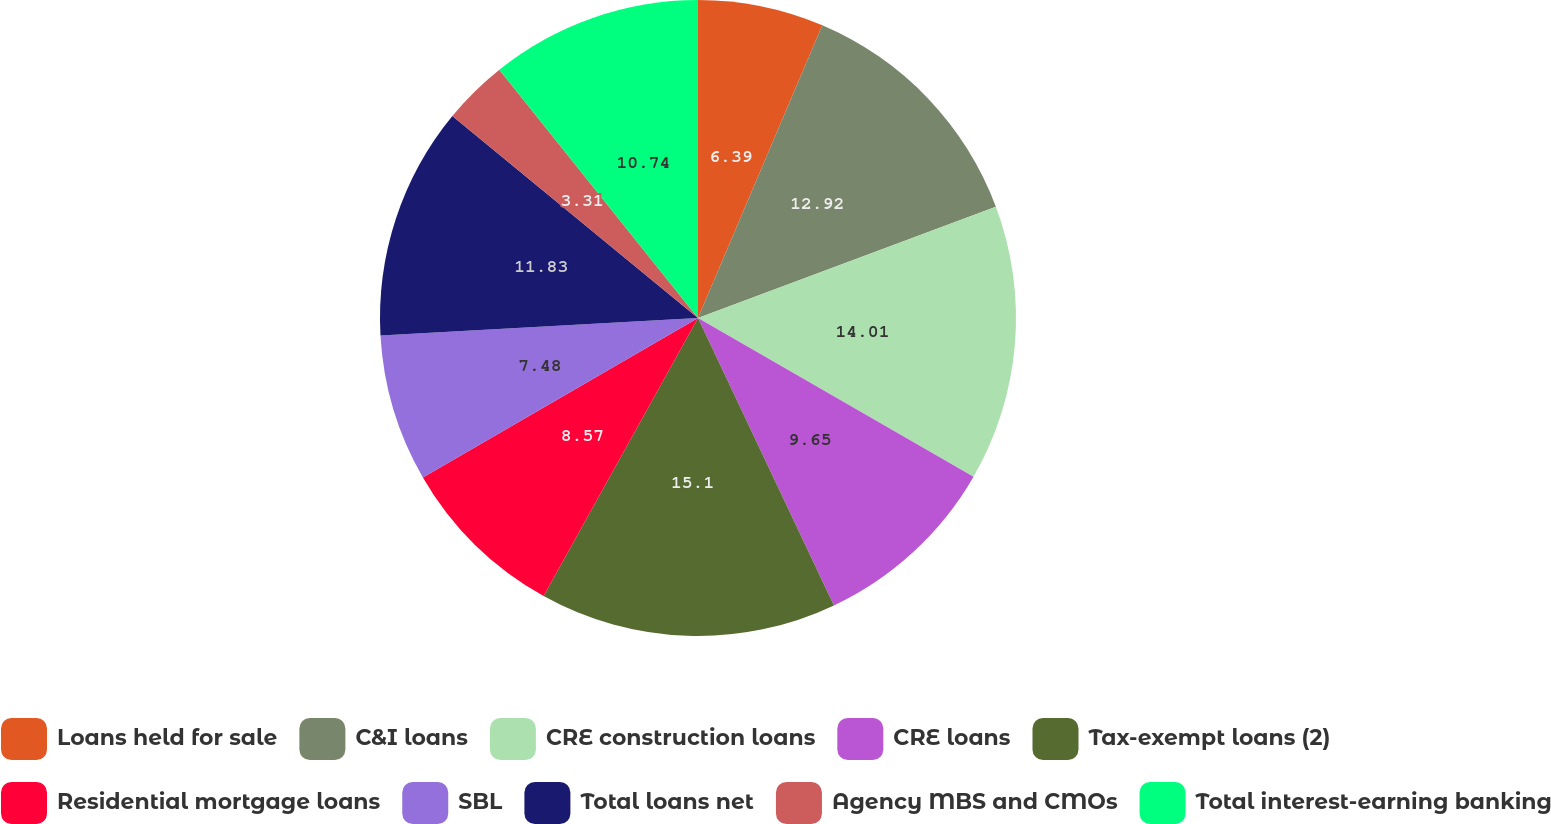Convert chart. <chart><loc_0><loc_0><loc_500><loc_500><pie_chart><fcel>Loans held for sale<fcel>C&I loans<fcel>CRE construction loans<fcel>CRE loans<fcel>Tax-exempt loans (2)<fcel>Residential mortgage loans<fcel>SBL<fcel>Total loans net<fcel>Agency MBS and CMOs<fcel>Total interest-earning banking<nl><fcel>6.39%<fcel>12.92%<fcel>14.01%<fcel>9.65%<fcel>15.1%<fcel>8.57%<fcel>7.48%<fcel>11.83%<fcel>3.31%<fcel>10.74%<nl></chart> 